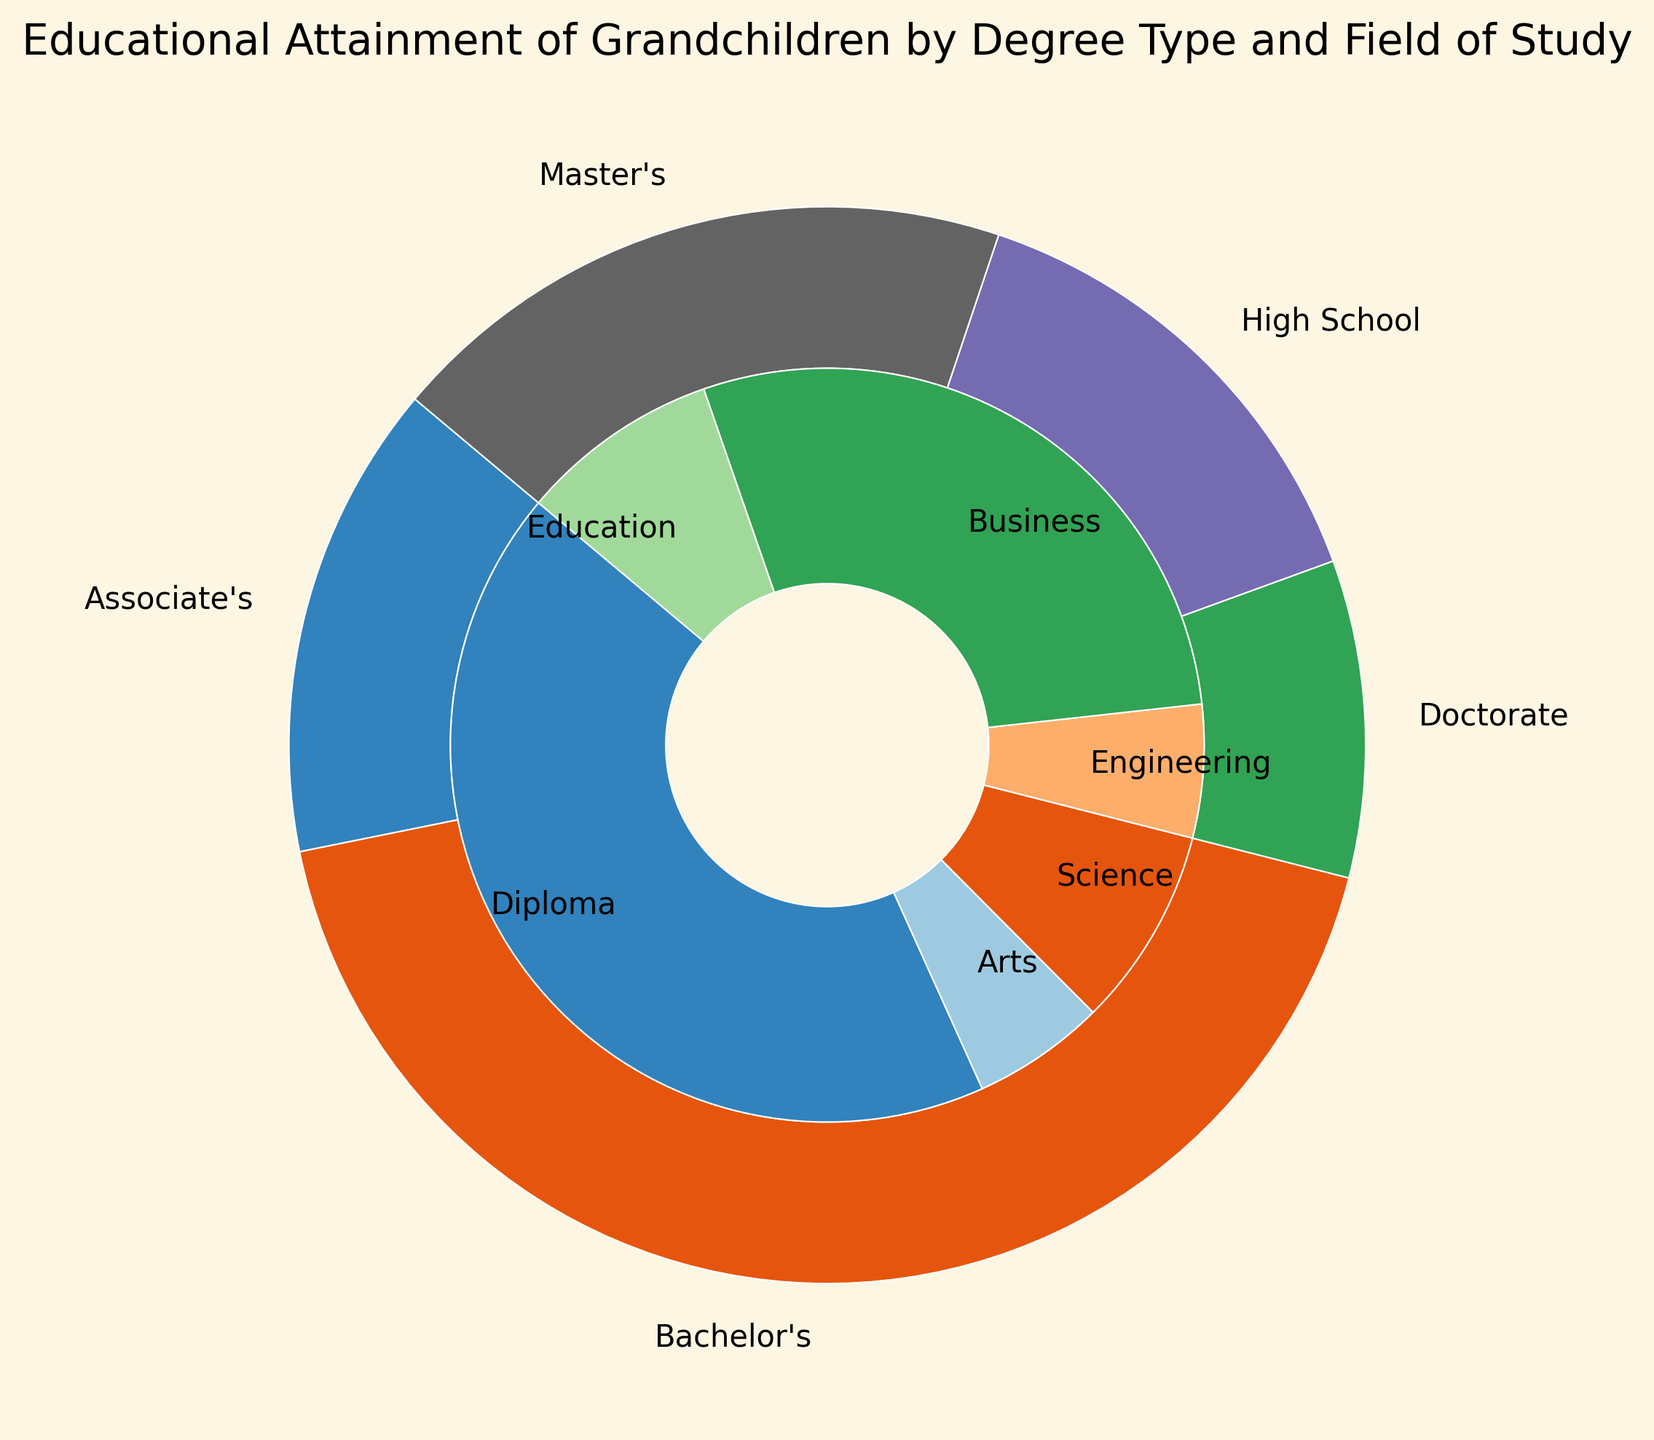Which degree type has the highest percentage? Look at the outer pie chart for the degree type with the largest slice; Engineering Bachelor's at 15% and High School Diploma are the contenders. Upon checking percentages, High School Diploma has the largest slice at 15%.
Answer: High School Diploma Which field of study has the lowest percentage? Look at the inner pie chart for the smallest slice. The slices for Doctorate in Engineering and Arts both represent 2% of the total.
Answer: Doctorate in Engineering, Arts How many total percentage points do Bachelor's degrees represent? Add the percentages for all Bachelor's degree fields: Engineering (15%), Arts (10%), Science (10%), and Business (10%). 15 + 10 + 10 + 10 = 45%.
Answer: 45% Compare the percentages of Science degrees at all levels. Which is highest? Identify percentage slices for Science in Associate’s (10%), Bachelor's (10%), Master’s (5%), and Doctorate (3%). Both Associate’s and Bachelor's level have the highest percentage at 10%.
Answer: Associate's and Bachelor's, equal at 10% Between Master's and Doctorate degrees, which has a larger total percentage? Add up the percentages for Master's fields: Engineering (5%), Arts (5%), Science (5%), and Education (5%), total: 20%. Do the same for Doctorate: Science (3%), Engineering (2%), Arts (2%), and Education (3%), total: 10%. Compare the totals, Master's has a larger share.
Answer: Master's Which fields of study appear in more than one degree type? Look for fields listed under multiple degree types. Arts appears in Associate's, Bachelor's, Master's, and Doctorate. Science in Associate's, Bachelor's, Master's, and Doctorate. Education in Master's and Doctorate.
Answer: Arts, Science, Education How does the percentage of Bachelor's in Engineering compare to the total percentage of Doctorate degrees? Bachelor's in Engineering is 15%. Calculate the total percentage of Doctorate degrees: Science (3%), Engineering (2%), Arts (2%), Education (3%). 3 + 2 + 2 + 3 = 10%. Compare 15% vs 10%.
Answer: Bachelor's in Engineering is higher What percentage of grandchildren have Master’s in Education? Check the inner pie chart for Master’s degrees. The slice labeled Education indicates it's 5%.
Answer: 5% Which degree type has more variety in fields of study: Master's or Bachelor's? Count fields of study for each: Bachelor's has 4 (Engineering, Arts, Science, Business) and Master's also has 4 (Engineering, Arts, Science, Education). Both have the same number of fields.
Answer: Equal What is the combined percentage of grandchildren with a degree in Education (Master’s and Doctorate)? Check slices for Master's and Doctorate in Education: Master's (5%) + Doctorate (3%). Total = 5 + 3 = 8%.
Answer: 8% 